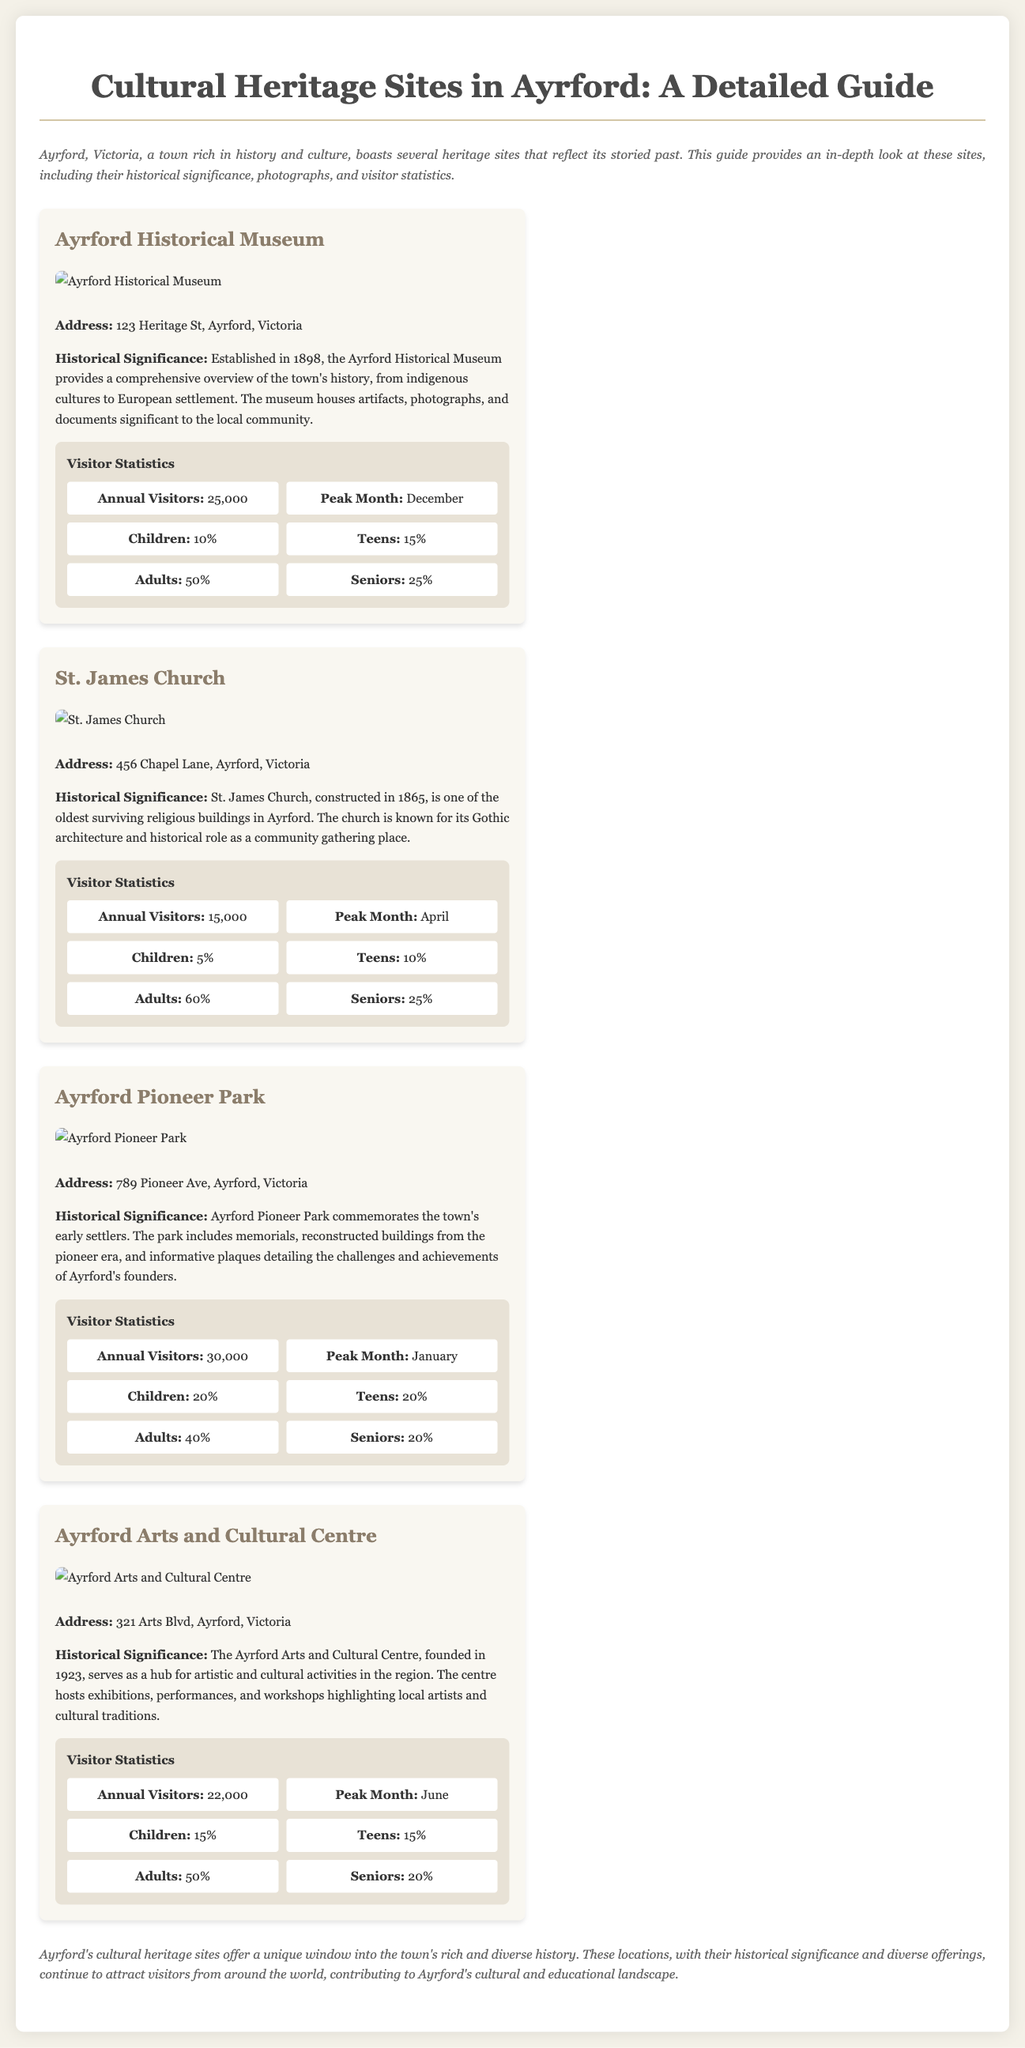what is the address of Ayrford Historical Museum? The address is provided in the document under the site information section for Ayrford Historical Museum.
Answer: 123 Heritage St, Ayrford, Victoria which year was St. James Church constructed? The year of construction for St. James Church is specifically mentioned in the historical significance section.
Answer: 1865 how many annual visitors does Ayrford Pioneer Park receive? The annual visitors statistic is given under the visitor statistics section for Ayrford Pioneer Park.
Answer: 30,000 what percentage of visitors to Ayrford Arts and Cultural Centre are seniors? The percentage of senior visitors is detailed in the visitor statistics for Ayrford Arts and Cultural Centre.
Answer: 20% which site has the peak month of December for visitors? The peak month for visits is indicated in the visitor statistics of the sites, and this question compares them.
Answer: Ayrford Historical Museum what is the primary function of the Ayrford Arts and Cultural Centre? This function is outlined in the historical significance section, describing the activities hosted at the centre.
Answer: Artistic and cultural activities which cultural heritage site was established in 1923? The founding year of the site is specified in the historical significance section.
Answer: Ayrford Arts and Cultural Centre what is the main architectural style of St. James Church? The document mentions this style in the historical significance of St. James Church.
Answer: Gothic architecture which site commemorates early settlers? The site dedicated to early settlers is clearly identified in the historical significance section.
Answer: Ayrford Pioneer Park 